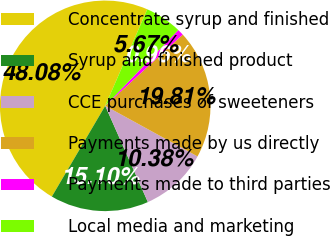Convert chart to OTSL. <chart><loc_0><loc_0><loc_500><loc_500><pie_chart><fcel>Concentrate syrup and finished<fcel>Syrup and finished product<fcel>CCE purchases of sweeteners<fcel>Payments made by us directly<fcel>Payments made to third parties<fcel>Local media and marketing<nl><fcel>48.08%<fcel>15.1%<fcel>10.38%<fcel>19.81%<fcel>0.96%<fcel>5.67%<nl></chart> 